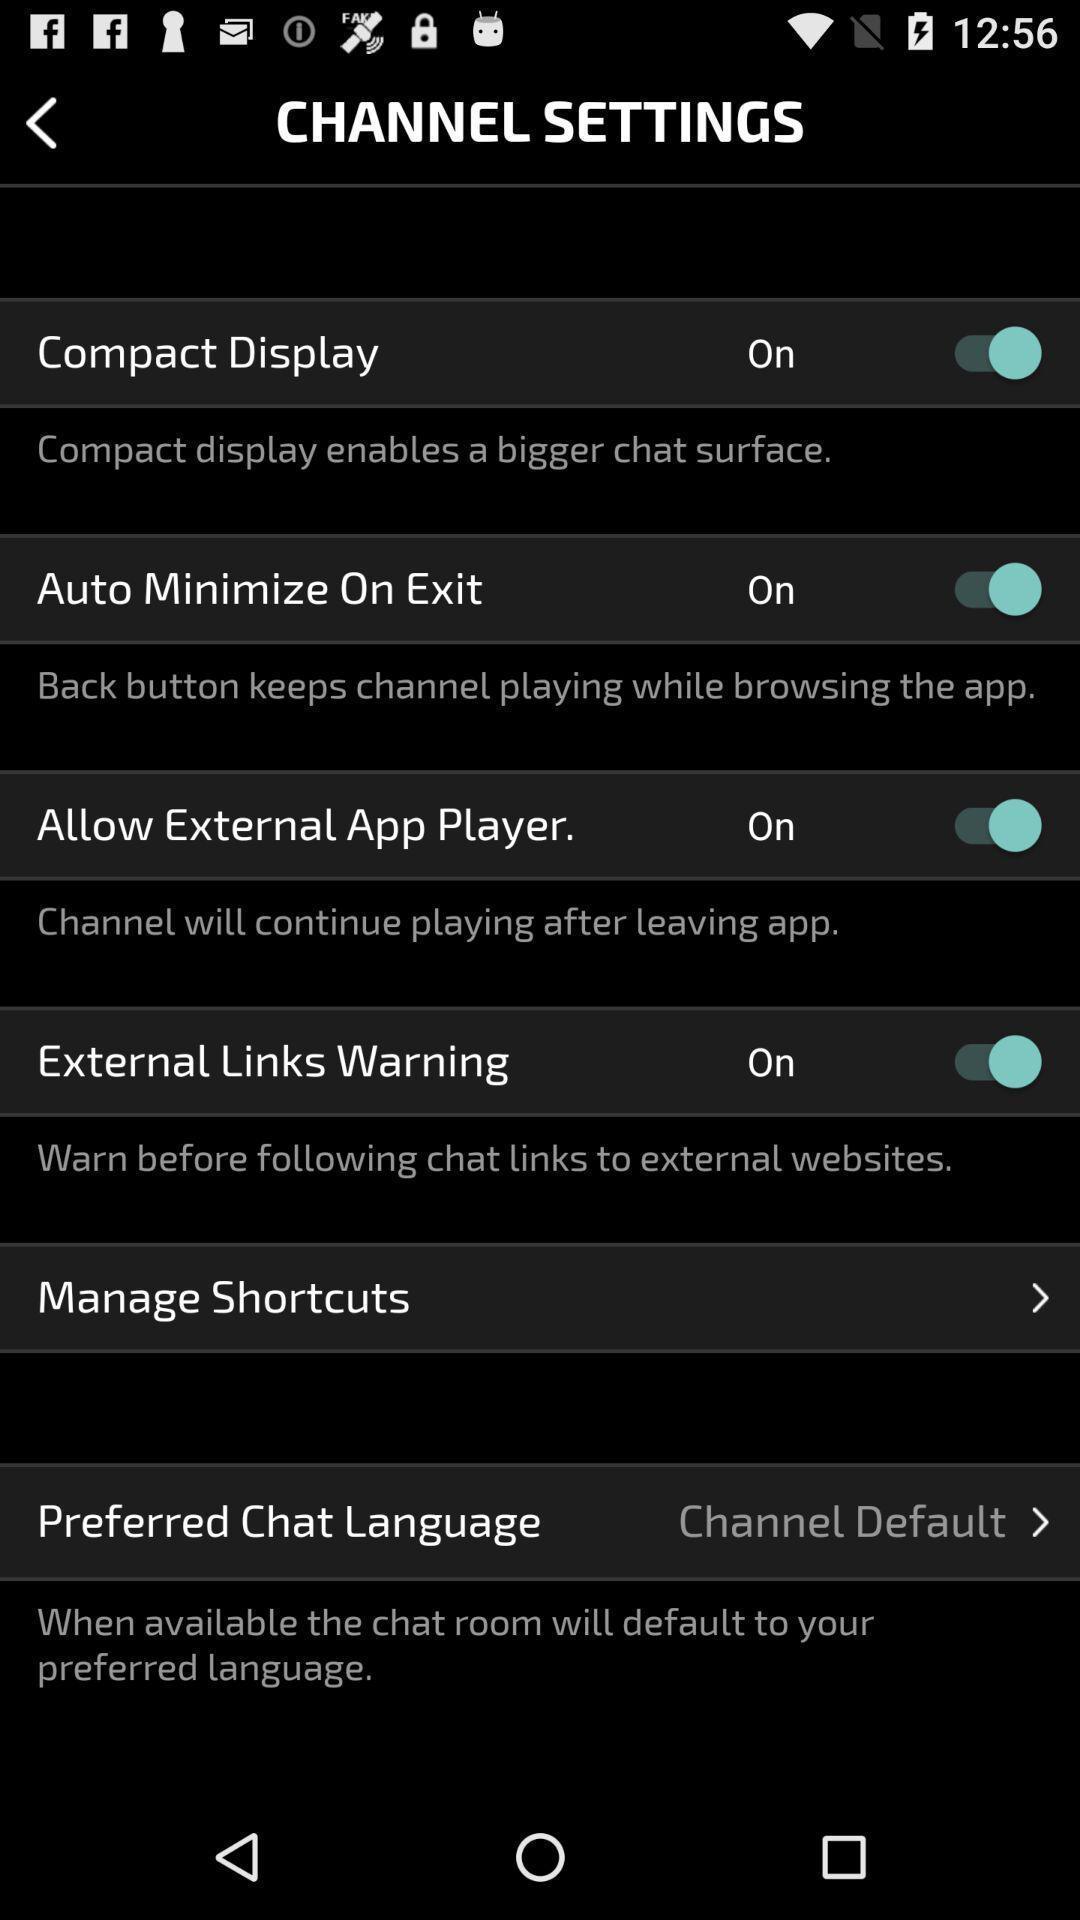Tell me what you see in this picture. Screen displaying list of channel settings. 